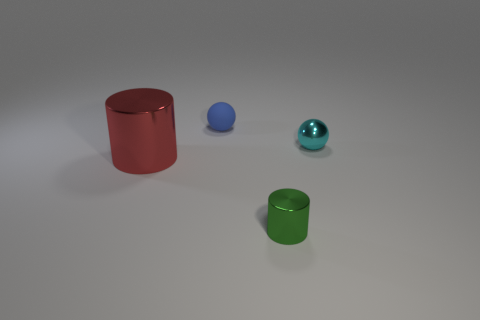How many small things are in front of the red metal thing that is in front of the shiny thing behind the red thing?
Keep it short and to the point. 1. Is the shape of the small green object the same as the red thing?
Give a very brief answer. Yes. Is there a small green metal thing of the same shape as the big metal object?
Your response must be concise. Yes. What shape is the green metal thing that is the same size as the blue rubber object?
Ensure brevity in your answer.  Cylinder. There is a tiny sphere behind the metal thing that is to the right of the tiny thing in front of the tiny cyan metal sphere; what is its material?
Your answer should be very brief. Rubber. Do the metal sphere and the red metal cylinder have the same size?
Your answer should be compact. No. What material is the tiny cyan ball?
Provide a succinct answer. Metal. There is a tiny thing in front of the large red shiny thing; is it the same shape as the big red object?
Make the answer very short. Yes. How many things are blue matte spheres or cyan metallic spheres?
Ensure brevity in your answer.  2. Does the tiny cyan ball on the right side of the tiny blue thing have the same material as the big thing?
Give a very brief answer. Yes. 